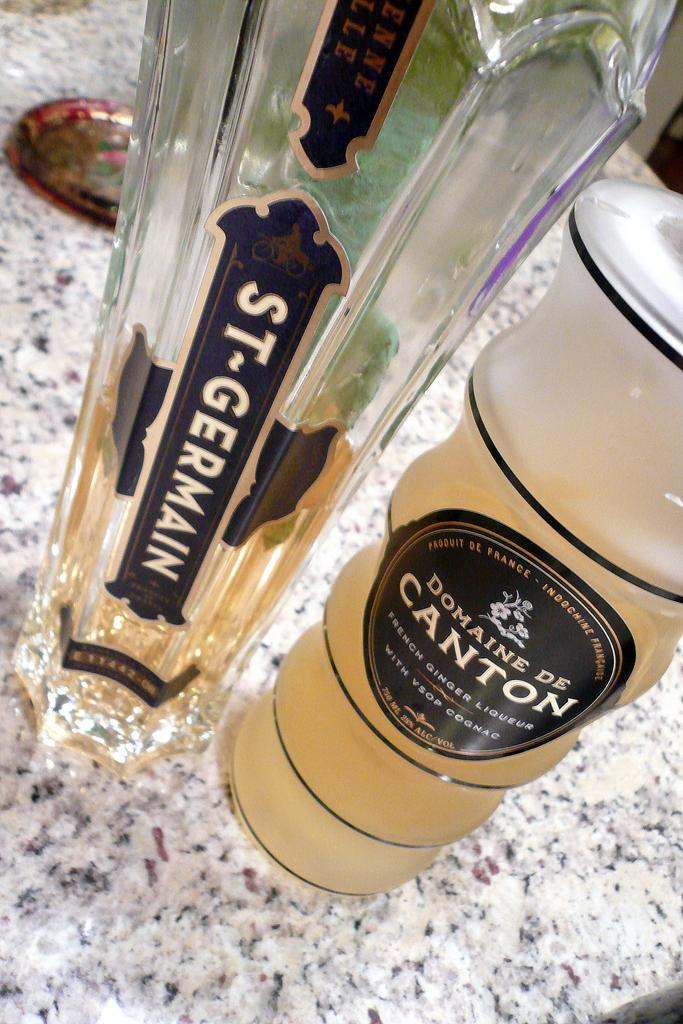<image>
Offer a succinct explanation of the picture presented. Two bottles of St Germain and Domaine De Canton are on a granite counter. 